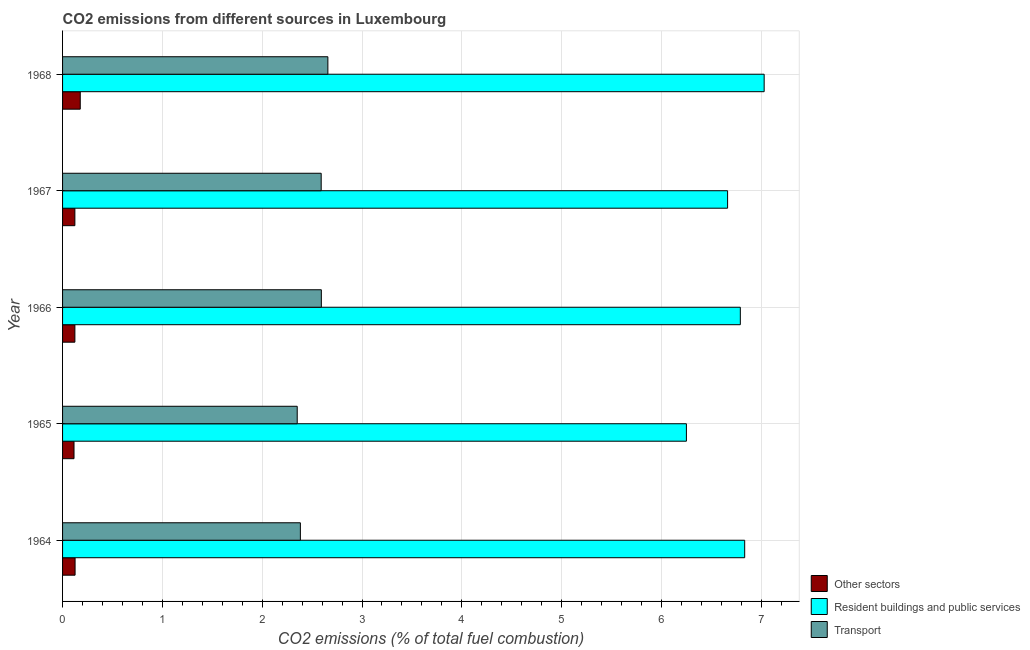How many different coloured bars are there?
Make the answer very short. 3. Are the number of bars per tick equal to the number of legend labels?
Keep it short and to the point. Yes. How many bars are there on the 3rd tick from the top?
Your answer should be compact. 3. How many bars are there on the 4th tick from the bottom?
Keep it short and to the point. 3. What is the label of the 4th group of bars from the top?
Make the answer very short. 1965. In how many cases, is the number of bars for a given year not equal to the number of legend labels?
Provide a succinct answer. 0. What is the percentage of co2 emissions from transport in 1967?
Your answer should be compact. 2.59. Across all years, what is the maximum percentage of co2 emissions from resident buildings and public services?
Your response must be concise. 7.03. Across all years, what is the minimum percentage of co2 emissions from other sectors?
Give a very brief answer. 0.11. In which year was the percentage of co2 emissions from resident buildings and public services maximum?
Provide a short and direct response. 1968. In which year was the percentage of co2 emissions from other sectors minimum?
Offer a very short reply. 1965. What is the total percentage of co2 emissions from transport in the graph?
Your answer should be very brief. 12.57. What is the difference between the percentage of co2 emissions from transport in 1964 and that in 1968?
Keep it short and to the point. -0.28. What is the difference between the percentage of co2 emissions from transport in 1967 and the percentage of co2 emissions from other sectors in 1965?
Your answer should be compact. 2.48. What is the average percentage of co2 emissions from resident buildings and public services per year?
Your response must be concise. 6.71. In the year 1968, what is the difference between the percentage of co2 emissions from transport and percentage of co2 emissions from other sectors?
Offer a very short reply. 2.48. In how many years, is the percentage of co2 emissions from other sectors greater than 3.6 %?
Provide a succinct answer. 0. What is the ratio of the percentage of co2 emissions from other sectors in 1965 to that in 1967?
Give a very brief answer. 0.93. Is the percentage of co2 emissions from other sectors in 1965 less than that in 1967?
Offer a very short reply. Yes. Is the difference between the percentage of co2 emissions from resident buildings and public services in 1964 and 1967 greater than the difference between the percentage of co2 emissions from other sectors in 1964 and 1967?
Make the answer very short. Yes. What is the difference between the highest and the second highest percentage of co2 emissions from transport?
Provide a succinct answer. 0.07. In how many years, is the percentage of co2 emissions from other sectors greater than the average percentage of co2 emissions from other sectors taken over all years?
Your response must be concise. 1. What does the 2nd bar from the top in 1966 represents?
Provide a succinct answer. Resident buildings and public services. What does the 2nd bar from the bottom in 1966 represents?
Your response must be concise. Resident buildings and public services. Is it the case that in every year, the sum of the percentage of co2 emissions from other sectors and percentage of co2 emissions from resident buildings and public services is greater than the percentage of co2 emissions from transport?
Provide a short and direct response. Yes. How many bars are there?
Offer a very short reply. 15. Does the graph contain any zero values?
Give a very brief answer. No. Does the graph contain grids?
Make the answer very short. Yes. Where does the legend appear in the graph?
Your answer should be compact. Bottom right. How many legend labels are there?
Your answer should be compact. 3. What is the title of the graph?
Ensure brevity in your answer.  CO2 emissions from different sources in Luxembourg. What is the label or title of the X-axis?
Offer a very short reply. CO2 emissions (% of total fuel combustion). What is the label or title of the Y-axis?
Give a very brief answer. Year. What is the CO2 emissions (% of total fuel combustion) in Other sectors in 1964?
Your response must be concise. 0.13. What is the CO2 emissions (% of total fuel combustion) of Resident buildings and public services in 1964?
Ensure brevity in your answer.  6.83. What is the CO2 emissions (% of total fuel combustion) in Transport in 1964?
Your response must be concise. 2.38. What is the CO2 emissions (% of total fuel combustion) of Other sectors in 1965?
Your answer should be compact. 0.11. What is the CO2 emissions (% of total fuel combustion) of Resident buildings and public services in 1965?
Offer a very short reply. 6.25. What is the CO2 emissions (% of total fuel combustion) in Transport in 1965?
Provide a short and direct response. 2.35. What is the CO2 emissions (% of total fuel combustion) in Other sectors in 1966?
Your answer should be compact. 0.12. What is the CO2 emissions (% of total fuel combustion) in Resident buildings and public services in 1966?
Give a very brief answer. 6.79. What is the CO2 emissions (% of total fuel combustion) in Transport in 1966?
Your answer should be compact. 2.59. What is the CO2 emissions (% of total fuel combustion) in Other sectors in 1967?
Your response must be concise. 0.12. What is the CO2 emissions (% of total fuel combustion) in Resident buildings and public services in 1967?
Your answer should be very brief. 6.66. What is the CO2 emissions (% of total fuel combustion) of Transport in 1967?
Keep it short and to the point. 2.59. What is the CO2 emissions (% of total fuel combustion) of Other sectors in 1968?
Offer a very short reply. 0.18. What is the CO2 emissions (% of total fuel combustion) in Resident buildings and public services in 1968?
Provide a succinct answer. 7.03. What is the CO2 emissions (% of total fuel combustion) of Transport in 1968?
Make the answer very short. 2.66. Across all years, what is the maximum CO2 emissions (% of total fuel combustion) in Other sectors?
Offer a terse response. 0.18. Across all years, what is the maximum CO2 emissions (% of total fuel combustion) of Resident buildings and public services?
Provide a short and direct response. 7.03. Across all years, what is the maximum CO2 emissions (% of total fuel combustion) of Transport?
Provide a succinct answer. 2.66. Across all years, what is the minimum CO2 emissions (% of total fuel combustion) in Other sectors?
Your answer should be compact. 0.11. Across all years, what is the minimum CO2 emissions (% of total fuel combustion) in Resident buildings and public services?
Keep it short and to the point. 6.25. Across all years, what is the minimum CO2 emissions (% of total fuel combustion) of Transport?
Offer a terse response. 2.35. What is the total CO2 emissions (% of total fuel combustion) of Other sectors in the graph?
Offer a terse response. 0.66. What is the total CO2 emissions (% of total fuel combustion) in Resident buildings and public services in the graph?
Keep it short and to the point. 33.57. What is the total CO2 emissions (% of total fuel combustion) of Transport in the graph?
Keep it short and to the point. 12.57. What is the difference between the CO2 emissions (% of total fuel combustion) in Other sectors in 1964 and that in 1965?
Ensure brevity in your answer.  0.01. What is the difference between the CO2 emissions (% of total fuel combustion) in Resident buildings and public services in 1964 and that in 1965?
Give a very brief answer. 0.58. What is the difference between the CO2 emissions (% of total fuel combustion) of Transport in 1964 and that in 1965?
Give a very brief answer. 0.03. What is the difference between the CO2 emissions (% of total fuel combustion) in Other sectors in 1964 and that in 1966?
Give a very brief answer. 0. What is the difference between the CO2 emissions (% of total fuel combustion) in Resident buildings and public services in 1964 and that in 1966?
Keep it short and to the point. 0.04. What is the difference between the CO2 emissions (% of total fuel combustion) of Transport in 1964 and that in 1966?
Your response must be concise. -0.21. What is the difference between the CO2 emissions (% of total fuel combustion) of Other sectors in 1964 and that in 1967?
Offer a terse response. 0. What is the difference between the CO2 emissions (% of total fuel combustion) of Resident buildings and public services in 1964 and that in 1967?
Make the answer very short. 0.17. What is the difference between the CO2 emissions (% of total fuel combustion) of Transport in 1964 and that in 1967?
Make the answer very short. -0.21. What is the difference between the CO2 emissions (% of total fuel combustion) of Other sectors in 1964 and that in 1968?
Provide a succinct answer. -0.05. What is the difference between the CO2 emissions (% of total fuel combustion) of Resident buildings and public services in 1964 and that in 1968?
Your answer should be compact. -0.2. What is the difference between the CO2 emissions (% of total fuel combustion) of Transport in 1964 and that in 1968?
Give a very brief answer. -0.28. What is the difference between the CO2 emissions (% of total fuel combustion) in Other sectors in 1965 and that in 1966?
Your answer should be compact. -0.01. What is the difference between the CO2 emissions (% of total fuel combustion) of Resident buildings and public services in 1965 and that in 1966?
Your answer should be very brief. -0.54. What is the difference between the CO2 emissions (% of total fuel combustion) in Transport in 1965 and that in 1966?
Provide a succinct answer. -0.24. What is the difference between the CO2 emissions (% of total fuel combustion) of Other sectors in 1965 and that in 1967?
Provide a short and direct response. -0.01. What is the difference between the CO2 emissions (% of total fuel combustion) of Resident buildings and public services in 1965 and that in 1967?
Provide a succinct answer. -0.41. What is the difference between the CO2 emissions (% of total fuel combustion) of Transport in 1965 and that in 1967?
Provide a succinct answer. -0.24. What is the difference between the CO2 emissions (% of total fuel combustion) of Other sectors in 1965 and that in 1968?
Your response must be concise. -0.06. What is the difference between the CO2 emissions (% of total fuel combustion) in Resident buildings and public services in 1965 and that in 1968?
Your response must be concise. -0.78. What is the difference between the CO2 emissions (% of total fuel combustion) in Transport in 1965 and that in 1968?
Offer a terse response. -0.31. What is the difference between the CO2 emissions (% of total fuel combustion) of Resident buildings and public services in 1966 and that in 1967?
Your answer should be very brief. 0.13. What is the difference between the CO2 emissions (% of total fuel combustion) of Transport in 1966 and that in 1967?
Ensure brevity in your answer.  0. What is the difference between the CO2 emissions (% of total fuel combustion) in Other sectors in 1966 and that in 1968?
Make the answer very short. -0.05. What is the difference between the CO2 emissions (% of total fuel combustion) in Resident buildings and public services in 1966 and that in 1968?
Ensure brevity in your answer.  -0.24. What is the difference between the CO2 emissions (% of total fuel combustion) of Transport in 1966 and that in 1968?
Ensure brevity in your answer.  -0.07. What is the difference between the CO2 emissions (% of total fuel combustion) in Other sectors in 1967 and that in 1968?
Make the answer very short. -0.05. What is the difference between the CO2 emissions (% of total fuel combustion) of Resident buildings and public services in 1967 and that in 1968?
Ensure brevity in your answer.  -0.37. What is the difference between the CO2 emissions (% of total fuel combustion) in Transport in 1967 and that in 1968?
Give a very brief answer. -0.07. What is the difference between the CO2 emissions (% of total fuel combustion) of Other sectors in 1964 and the CO2 emissions (% of total fuel combustion) of Resident buildings and public services in 1965?
Provide a short and direct response. -6.12. What is the difference between the CO2 emissions (% of total fuel combustion) of Other sectors in 1964 and the CO2 emissions (% of total fuel combustion) of Transport in 1965?
Provide a succinct answer. -2.23. What is the difference between the CO2 emissions (% of total fuel combustion) in Resident buildings and public services in 1964 and the CO2 emissions (% of total fuel combustion) in Transport in 1965?
Your answer should be very brief. 4.48. What is the difference between the CO2 emissions (% of total fuel combustion) of Other sectors in 1964 and the CO2 emissions (% of total fuel combustion) of Resident buildings and public services in 1966?
Ensure brevity in your answer.  -6.66. What is the difference between the CO2 emissions (% of total fuel combustion) in Other sectors in 1964 and the CO2 emissions (% of total fuel combustion) in Transport in 1966?
Offer a terse response. -2.47. What is the difference between the CO2 emissions (% of total fuel combustion) of Resident buildings and public services in 1964 and the CO2 emissions (% of total fuel combustion) of Transport in 1966?
Offer a terse response. 4.24. What is the difference between the CO2 emissions (% of total fuel combustion) in Other sectors in 1964 and the CO2 emissions (% of total fuel combustion) in Resident buildings and public services in 1967?
Provide a short and direct response. -6.54. What is the difference between the CO2 emissions (% of total fuel combustion) of Other sectors in 1964 and the CO2 emissions (% of total fuel combustion) of Transport in 1967?
Make the answer very short. -2.47. What is the difference between the CO2 emissions (% of total fuel combustion) of Resident buildings and public services in 1964 and the CO2 emissions (% of total fuel combustion) of Transport in 1967?
Give a very brief answer. 4.24. What is the difference between the CO2 emissions (% of total fuel combustion) of Other sectors in 1964 and the CO2 emissions (% of total fuel combustion) of Resident buildings and public services in 1968?
Ensure brevity in your answer.  -6.9. What is the difference between the CO2 emissions (% of total fuel combustion) of Other sectors in 1964 and the CO2 emissions (% of total fuel combustion) of Transport in 1968?
Provide a short and direct response. -2.53. What is the difference between the CO2 emissions (% of total fuel combustion) of Resident buildings and public services in 1964 and the CO2 emissions (% of total fuel combustion) of Transport in 1968?
Offer a very short reply. 4.18. What is the difference between the CO2 emissions (% of total fuel combustion) of Other sectors in 1965 and the CO2 emissions (% of total fuel combustion) of Resident buildings and public services in 1966?
Your response must be concise. -6.68. What is the difference between the CO2 emissions (% of total fuel combustion) in Other sectors in 1965 and the CO2 emissions (% of total fuel combustion) in Transport in 1966?
Make the answer very short. -2.48. What is the difference between the CO2 emissions (% of total fuel combustion) in Resident buildings and public services in 1965 and the CO2 emissions (% of total fuel combustion) in Transport in 1966?
Provide a short and direct response. 3.66. What is the difference between the CO2 emissions (% of total fuel combustion) in Other sectors in 1965 and the CO2 emissions (% of total fuel combustion) in Resident buildings and public services in 1967?
Offer a terse response. -6.55. What is the difference between the CO2 emissions (% of total fuel combustion) in Other sectors in 1965 and the CO2 emissions (% of total fuel combustion) in Transport in 1967?
Ensure brevity in your answer.  -2.48. What is the difference between the CO2 emissions (% of total fuel combustion) of Resident buildings and public services in 1965 and the CO2 emissions (% of total fuel combustion) of Transport in 1967?
Offer a very short reply. 3.66. What is the difference between the CO2 emissions (% of total fuel combustion) of Other sectors in 1965 and the CO2 emissions (% of total fuel combustion) of Resident buildings and public services in 1968?
Make the answer very short. -6.91. What is the difference between the CO2 emissions (% of total fuel combustion) of Other sectors in 1965 and the CO2 emissions (% of total fuel combustion) of Transport in 1968?
Provide a succinct answer. -2.54. What is the difference between the CO2 emissions (% of total fuel combustion) of Resident buildings and public services in 1965 and the CO2 emissions (% of total fuel combustion) of Transport in 1968?
Your answer should be very brief. 3.59. What is the difference between the CO2 emissions (% of total fuel combustion) in Other sectors in 1966 and the CO2 emissions (% of total fuel combustion) in Resident buildings and public services in 1967?
Offer a terse response. -6.54. What is the difference between the CO2 emissions (% of total fuel combustion) of Other sectors in 1966 and the CO2 emissions (% of total fuel combustion) of Transport in 1967?
Keep it short and to the point. -2.47. What is the difference between the CO2 emissions (% of total fuel combustion) in Resident buildings and public services in 1966 and the CO2 emissions (% of total fuel combustion) in Transport in 1967?
Offer a terse response. 4.2. What is the difference between the CO2 emissions (% of total fuel combustion) of Other sectors in 1966 and the CO2 emissions (% of total fuel combustion) of Resident buildings and public services in 1968?
Provide a short and direct response. -6.91. What is the difference between the CO2 emissions (% of total fuel combustion) in Other sectors in 1966 and the CO2 emissions (% of total fuel combustion) in Transport in 1968?
Provide a succinct answer. -2.53. What is the difference between the CO2 emissions (% of total fuel combustion) of Resident buildings and public services in 1966 and the CO2 emissions (% of total fuel combustion) of Transport in 1968?
Keep it short and to the point. 4.13. What is the difference between the CO2 emissions (% of total fuel combustion) of Other sectors in 1967 and the CO2 emissions (% of total fuel combustion) of Resident buildings and public services in 1968?
Your answer should be very brief. -6.91. What is the difference between the CO2 emissions (% of total fuel combustion) of Other sectors in 1967 and the CO2 emissions (% of total fuel combustion) of Transport in 1968?
Provide a succinct answer. -2.53. What is the difference between the CO2 emissions (% of total fuel combustion) of Resident buildings and public services in 1967 and the CO2 emissions (% of total fuel combustion) of Transport in 1968?
Make the answer very short. 4. What is the average CO2 emissions (% of total fuel combustion) in Other sectors per year?
Ensure brevity in your answer.  0.13. What is the average CO2 emissions (% of total fuel combustion) of Resident buildings and public services per year?
Provide a succinct answer. 6.71. What is the average CO2 emissions (% of total fuel combustion) of Transport per year?
Your answer should be compact. 2.52. In the year 1964, what is the difference between the CO2 emissions (% of total fuel combustion) in Other sectors and CO2 emissions (% of total fuel combustion) in Resident buildings and public services?
Provide a succinct answer. -6.71. In the year 1964, what is the difference between the CO2 emissions (% of total fuel combustion) in Other sectors and CO2 emissions (% of total fuel combustion) in Transport?
Make the answer very short. -2.26. In the year 1964, what is the difference between the CO2 emissions (% of total fuel combustion) in Resident buildings and public services and CO2 emissions (% of total fuel combustion) in Transport?
Offer a very short reply. 4.45. In the year 1965, what is the difference between the CO2 emissions (% of total fuel combustion) of Other sectors and CO2 emissions (% of total fuel combustion) of Resident buildings and public services?
Make the answer very short. -6.14. In the year 1965, what is the difference between the CO2 emissions (% of total fuel combustion) of Other sectors and CO2 emissions (% of total fuel combustion) of Transport?
Offer a terse response. -2.24. In the year 1965, what is the difference between the CO2 emissions (% of total fuel combustion) of Resident buildings and public services and CO2 emissions (% of total fuel combustion) of Transport?
Offer a terse response. 3.9. In the year 1966, what is the difference between the CO2 emissions (% of total fuel combustion) of Other sectors and CO2 emissions (% of total fuel combustion) of Resident buildings and public services?
Ensure brevity in your answer.  -6.67. In the year 1966, what is the difference between the CO2 emissions (% of total fuel combustion) of Other sectors and CO2 emissions (% of total fuel combustion) of Transport?
Ensure brevity in your answer.  -2.47. In the year 1966, what is the difference between the CO2 emissions (% of total fuel combustion) of Resident buildings and public services and CO2 emissions (% of total fuel combustion) of Transport?
Make the answer very short. 4.2. In the year 1967, what is the difference between the CO2 emissions (% of total fuel combustion) of Other sectors and CO2 emissions (% of total fuel combustion) of Resident buildings and public services?
Your answer should be compact. -6.54. In the year 1967, what is the difference between the CO2 emissions (% of total fuel combustion) in Other sectors and CO2 emissions (% of total fuel combustion) in Transport?
Offer a terse response. -2.47. In the year 1967, what is the difference between the CO2 emissions (% of total fuel combustion) of Resident buildings and public services and CO2 emissions (% of total fuel combustion) of Transport?
Give a very brief answer. 4.07. In the year 1968, what is the difference between the CO2 emissions (% of total fuel combustion) in Other sectors and CO2 emissions (% of total fuel combustion) in Resident buildings and public services?
Provide a short and direct response. -6.85. In the year 1968, what is the difference between the CO2 emissions (% of total fuel combustion) in Other sectors and CO2 emissions (% of total fuel combustion) in Transport?
Provide a short and direct response. -2.48. In the year 1968, what is the difference between the CO2 emissions (% of total fuel combustion) in Resident buildings and public services and CO2 emissions (% of total fuel combustion) in Transport?
Provide a short and direct response. 4.37. What is the ratio of the CO2 emissions (% of total fuel combustion) in Other sectors in 1964 to that in 1965?
Give a very brief answer. 1.09. What is the ratio of the CO2 emissions (% of total fuel combustion) in Resident buildings and public services in 1964 to that in 1965?
Your response must be concise. 1.09. What is the ratio of the CO2 emissions (% of total fuel combustion) in Transport in 1964 to that in 1965?
Give a very brief answer. 1.01. What is the ratio of the CO2 emissions (% of total fuel combustion) of Other sectors in 1964 to that in 1966?
Provide a short and direct response. 1.02. What is the ratio of the CO2 emissions (% of total fuel combustion) in Resident buildings and public services in 1964 to that in 1966?
Your response must be concise. 1.01. What is the ratio of the CO2 emissions (% of total fuel combustion) in Transport in 1964 to that in 1966?
Provide a short and direct response. 0.92. What is the ratio of the CO2 emissions (% of total fuel combustion) in Other sectors in 1964 to that in 1967?
Ensure brevity in your answer.  1.02. What is the ratio of the CO2 emissions (% of total fuel combustion) in Resident buildings and public services in 1964 to that in 1967?
Offer a very short reply. 1.03. What is the ratio of the CO2 emissions (% of total fuel combustion) in Transport in 1964 to that in 1967?
Make the answer very short. 0.92. What is the ratio of the CO2 emissions (% of total fuel combustion) of Other sectors in 1964 to that in 1968?
Provide a succinct answer. 0.71. What is the ratio of the CO2 emissions (% of total fuel combustion) of Resident buildings and public services in 1964 to that in 1968?
Your answer should be compact. 0.97. What is the ratio of the CO2 emissions (% of total fuel combustion) in Transport in 1964 to that in 1968?
Ensure brevity in your answer.  0.9. What is the ratio of the CO2 emissions (% of total fuel combustion) in Other sectors in 1965 to that in 1966?
Ensure brevity in your answer.  0.93. What is the ratio of the CO2 emissions (% of total fuel combustion) of Resident buildings and public services in 1965 to that in 1966?
Provide a succinct answer. 0.92. What is the ratio of the CO2 emissions (% of total fuel combustion) of Transport in 1965 to that in 1966?
Your answer should be very brief. 0.91. What is the ratio of the CO2 emissions (% of total fuel combustion) in Other sectors in 1965 to that in 1967?
Provide a short and direct response. 0.93. What is the ratio of the CO2 emissions (% of total fuel combustion) of Resident buildings and public services in 1965 to that in 1967?
Provide a short and direct response. 0.94. What is the ratio of the CO2 emissions (% of total fuel combustion) of Transport in 1965 to that in 1967?
Provide a short and direct response. 0.91. What is the ratio of the CO2 emissions (% of total fuel combustion) in Other sectors in 1965 to that in 1968?
Ensure brevity in your answer.  0.65. What is the ratio of the CO2 emissions (% of total fuel combustion) in Resident buildings and public services in 1965 to that in 1968?
Your answer should be compact. 0.89. What is the ratio of the CO2 emissions (% of total fuel combustion) of Transport in 1965 to that in 1968?
Your answer should be very brief. 0.88. What is the ratio of the CO2 emissions (% of total fuel combustion) in Resident buildings and public services in 1966 to that in 1967?
Your answer should be compact. 1.02. What is the ratio of the CO2 emissions (% of total fuel combustion) of Transport in 1966 to that in 1967?
Keep it short and to the point. 1. What is the ratio of the CO2 emissions (% of total fuel combustion) in Other sectors in 1966 to that in 1968?
Provide a succinct answer. 0.7. What is the ratio of the CO2 emissions (% of total fuel combustion) of Resident buildings and public services in 1966 to that in 1968?
Your response must be concise. 0.97. What is the ratio of the CO2 emissions (% of total fuel combustion) in Transport in 1966 to that in 1968?
Provide a succinct answer. 0.98. What is the ratio of the CO2 emissions (% of total fuel combustion) of Other sectors in 1967 to that in 1968?
Your answer should be compact. 0.7. What is the ratio of the CO2 emissions (% of total fuel combustion) in Resident buildings and public services in 1967 to that in 1968?
Give a very brief answer. 0.95. What is the ratio of the CO2 emissions (% of total fuel combustion) of Transport in 1967 to that in 1968?
Your response must be concise. 0.97. What is the difference between the highest and the second highest CO2 emissions (% of total fuel combustion) in Other sectors?
Your answer should be very brief. 0.05. What is the difference between the highest and the second highest CO2 emissions (% of total fuel combustion) in Resident buildings and public services?
Your answer should be compact. 0.2. What is the difference between the highest and the second highest CO2 emissions (% of total fuel combustion) of Transport?
Your answer should be very brief. 0.07. What is the difference between the highest and the lowest CO2 emissions (% of total fuel combustion) of Other sectors?
Ensure brevity in your answer.  0.06. What is the difference between the highest and the lowest CO2 emissions (% of total fuel combustion) of Resident buildings and public services?
Provide a short and direct response. 0.78. What is the difference between the highest and the lowest CO2 emissions (% of total fuel combustion) of Transport?
Offer a terse response. 0.31. 